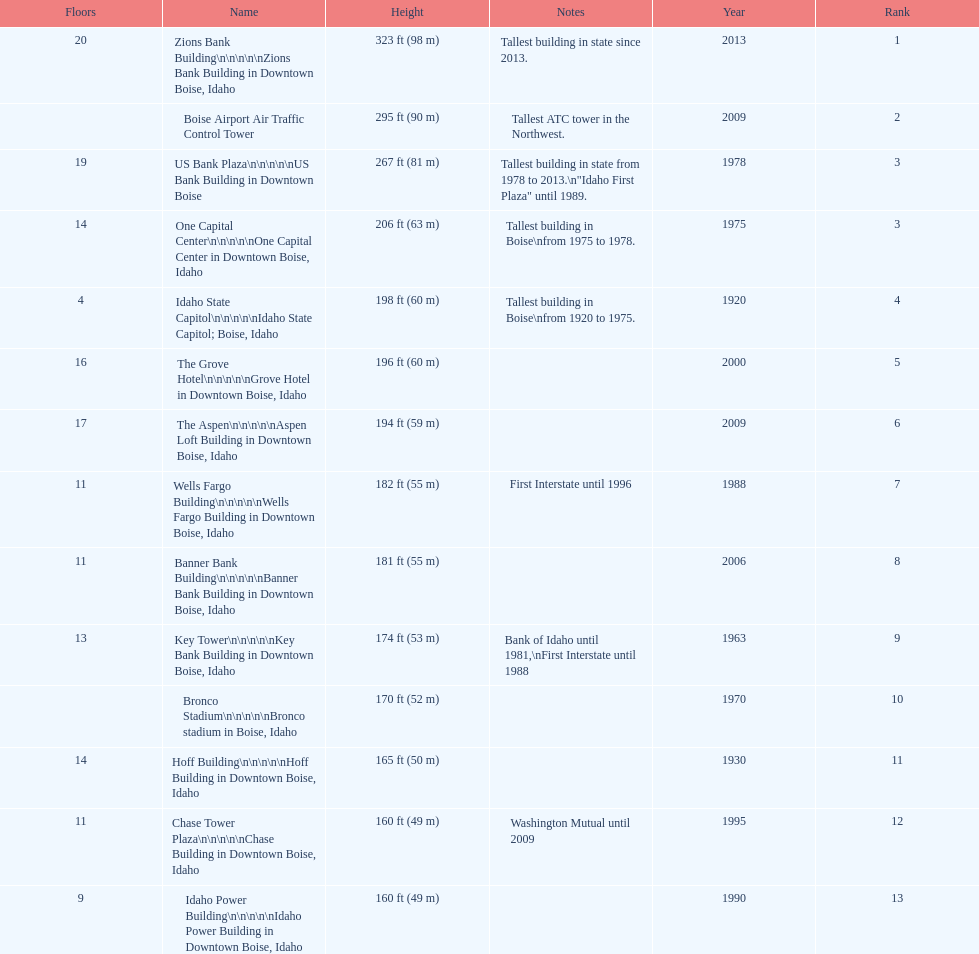Is the bronco stadium above or below 150 ft? Above. 